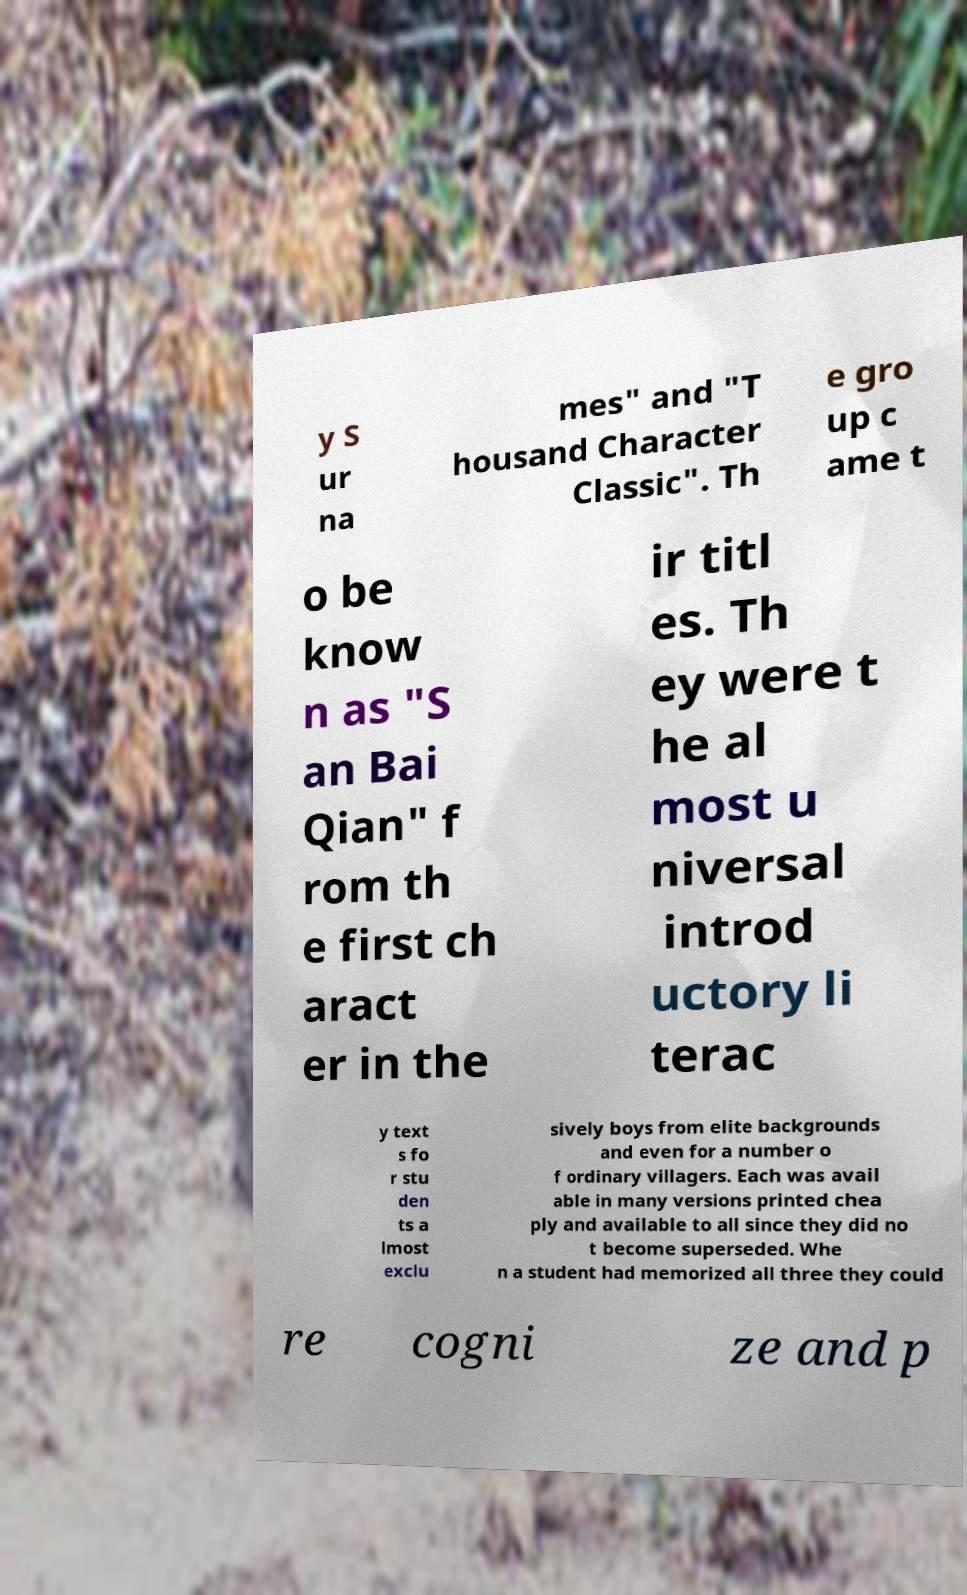Can you read and provide the text displayed in the image?This photo seems to have some interesting text. Can you extract and type it out for me? y S ur na mes" and "T housand Character Classic". Th e gro up c ame t o be know n as "S an Bai Qian" f rom th e first ch aract er in the ir titl es. Th ey were t he al most u niversal introd uctory li terac y text s fo r stu den ts a lmost exclu sively boys from elite backgrounds and even for a number o f ordinary villagers. Each was avail able in many versions printed chea ply and available to all since they did no t become superseded. Whe n a student had memorized all three they could re cogni ze and p 